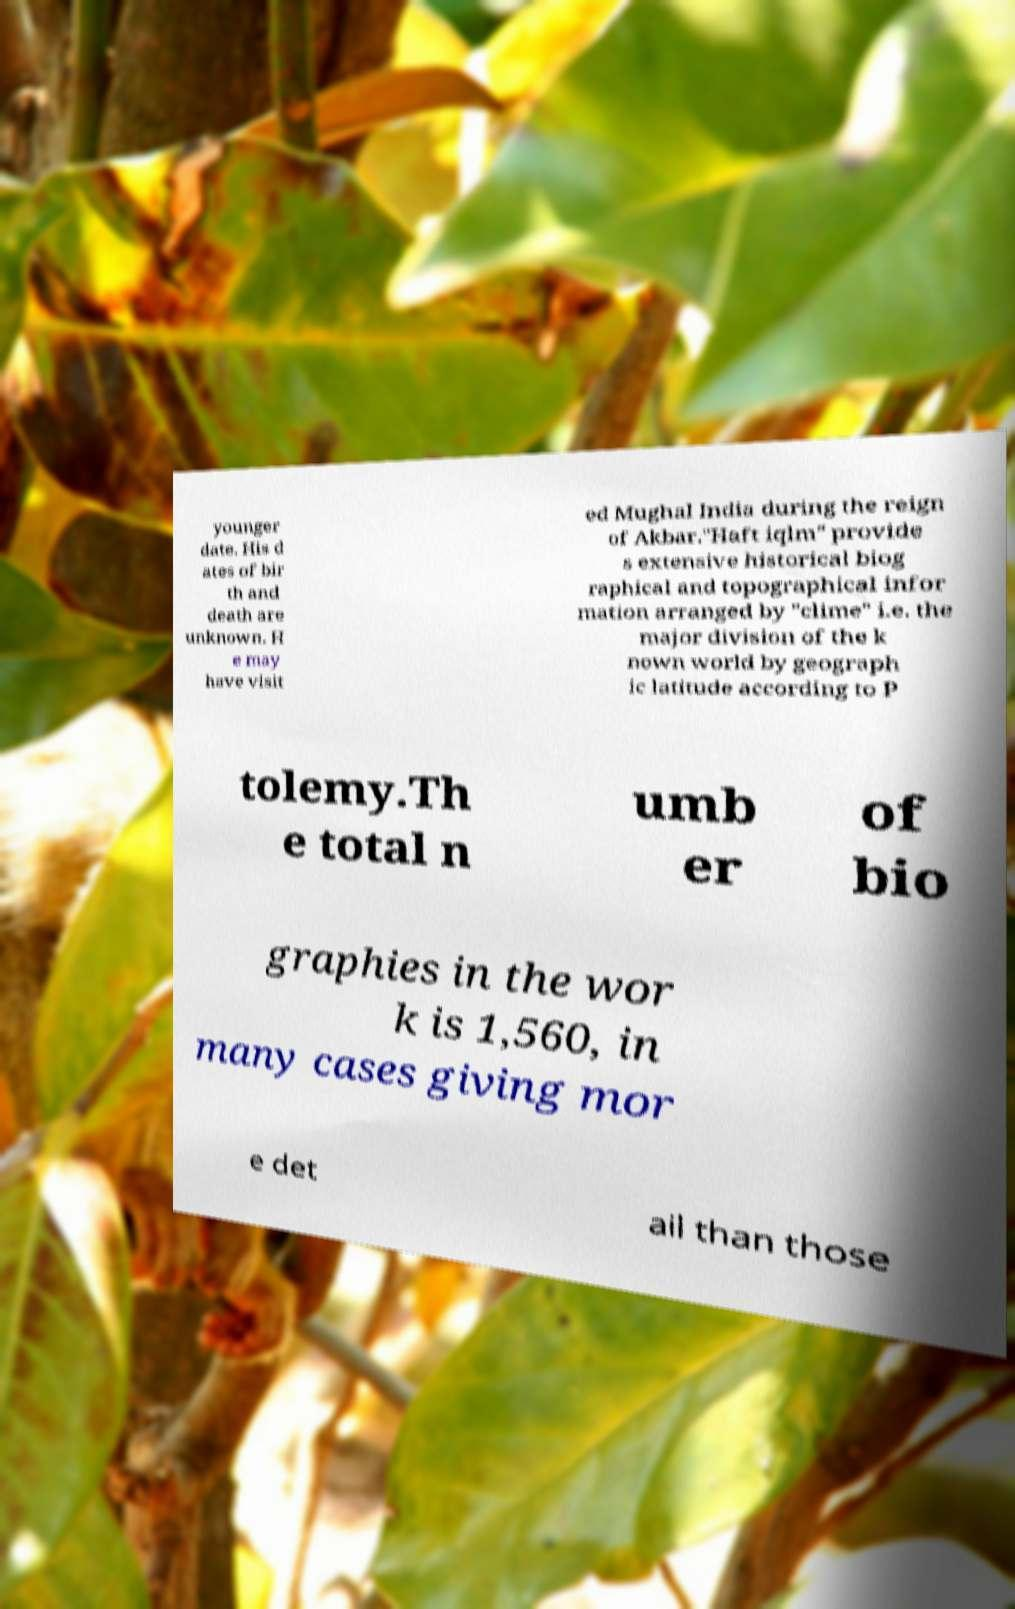Can you read and provide the text displayed in the image?This photo seems to have some interesting text. Can you extract and type it out for me? younger date. His d ates of bir th and death are unknown. H e may have visit ed Mughal India during the reign of Akbar."Haft iqlm" provide s extensive historical biog raphical and topographical infor mation arranged by "clime" i.e. the major division of the k nown world by geograph ic latitude according to P tolemy.Th e total n umb er of bio graphies in the wor k is 1,560, in many cases giving mor e det ail than those 